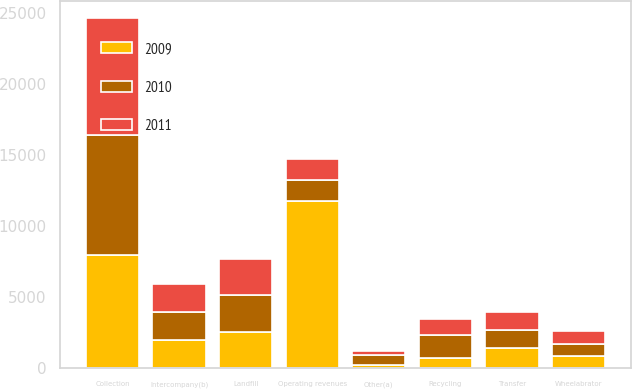Convert chart. <chart><loc_0><loc_0><loc_500><loc_500><stacked_bar_chart><ecel><fcel>Collection<fcel>Landfill<fcel>Transfer<fcel>Wheelabrator<fcel>Recycling<fcel>Other(a)<fcel>Intercompany(b)<fcel>Operating revenues<nl><fcel>2010<fcel>8406<fcel>2611<fcel>1280<fcel>877<fcel>1580<fcel>655<fcel>2031<fcel>1481.5<nl><fcel>2011<fcel>8247<fcel>2540<fcel>1318<fcel>889<fcel>1169<fcel>314<fcel>1962<fcel>1481.5<nl><fcel>2009<fcel>7980<fcel>2547<fcel>1383<fcel>841<fcel>741<fcel>245<fcel>1946<fcel>11791<nl></chart> 